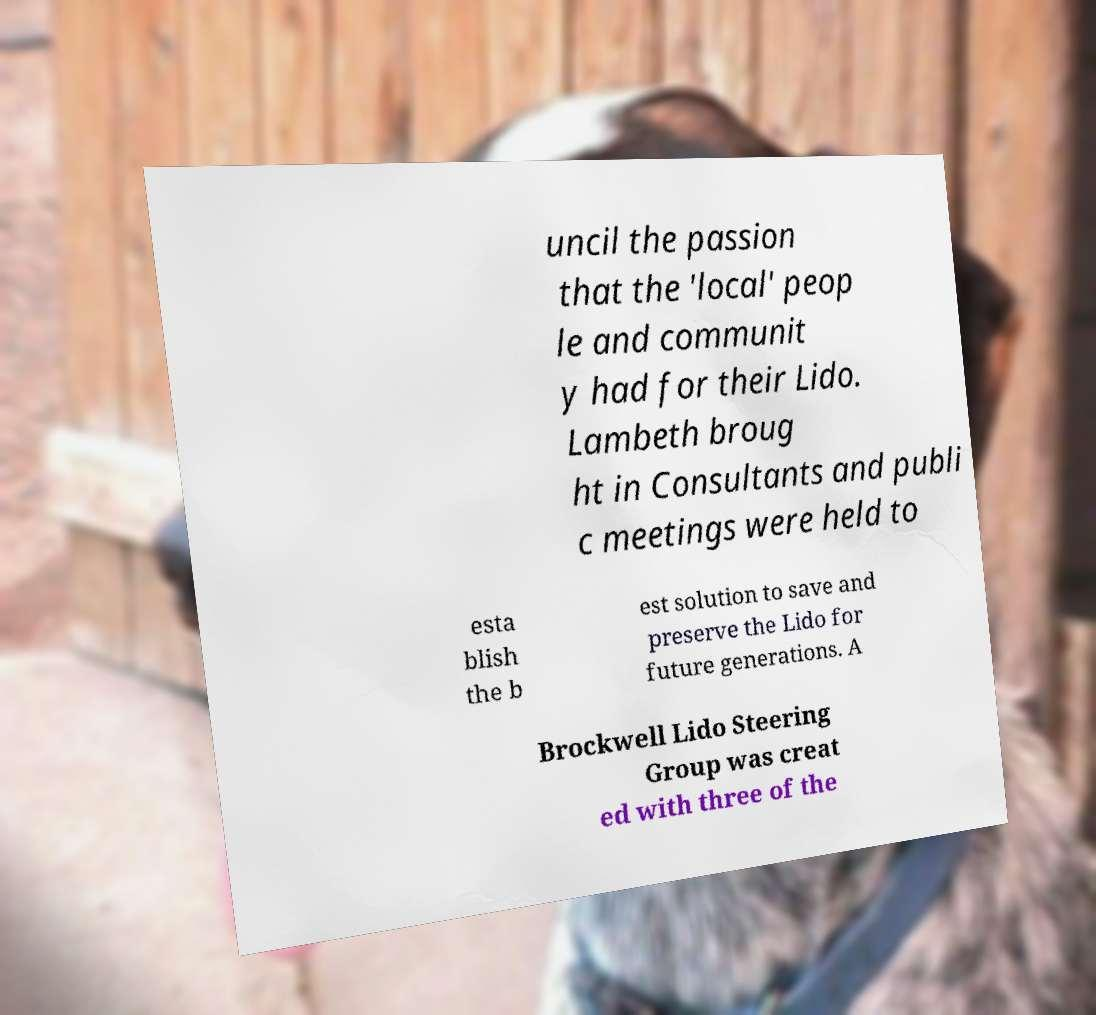Can you read and provide the text displayed in the image?This photo seems to have some interesting text. Can you extract and type it out for me? uncil the passion that the 'local' peop le and communit y had for their Lido. Lambeth broug ht in Consultants and publi c meetings were held to esta blish the b est solution to save and preserve the Lido for future generations. A Brockwell Lido Steering Group was creat ed with three of the 